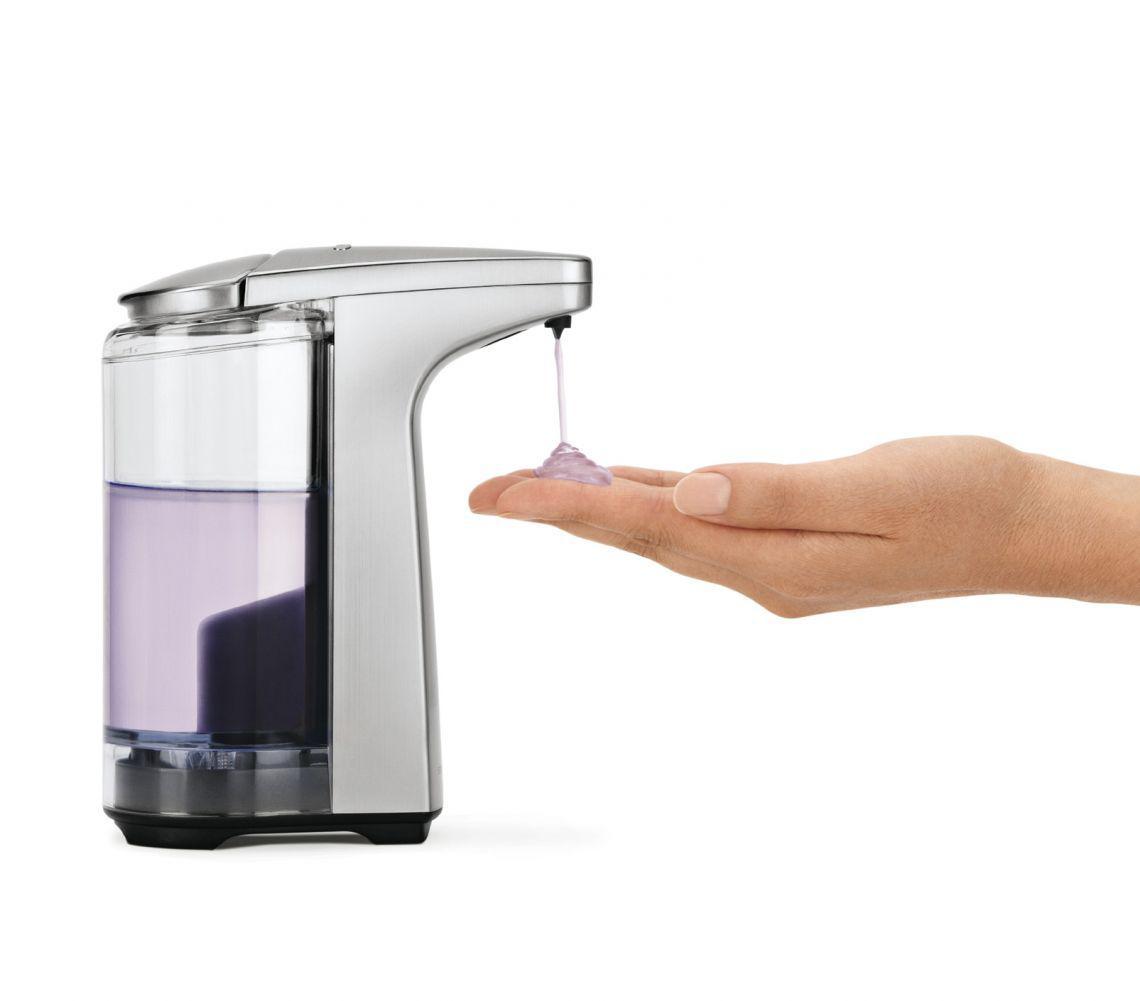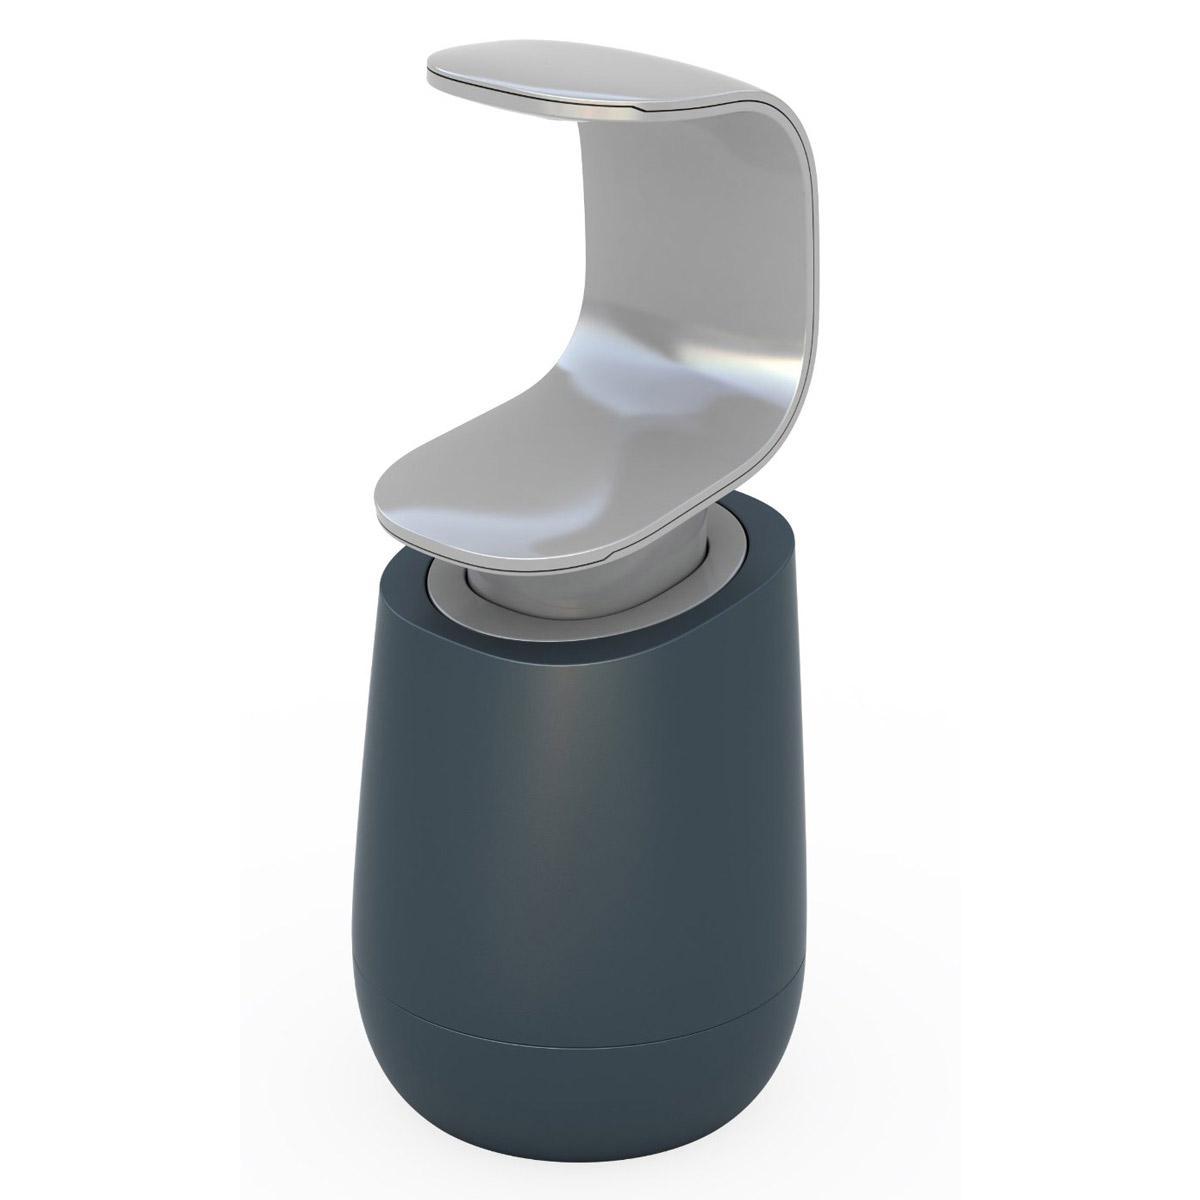The first image is the image on the left, the second image is the image on the right. For the images displayed, is the sentence "The combined images show four complete pump-top dispensers, all of them transparent." factually correct? Answer yes or no. No. The first image is the image on the left, the second image is the image on the right. Evaluate the accuracy of this statement regarding the images: "The right image contains at least two dispensers.". Is it true? Answer yes or no. No. 